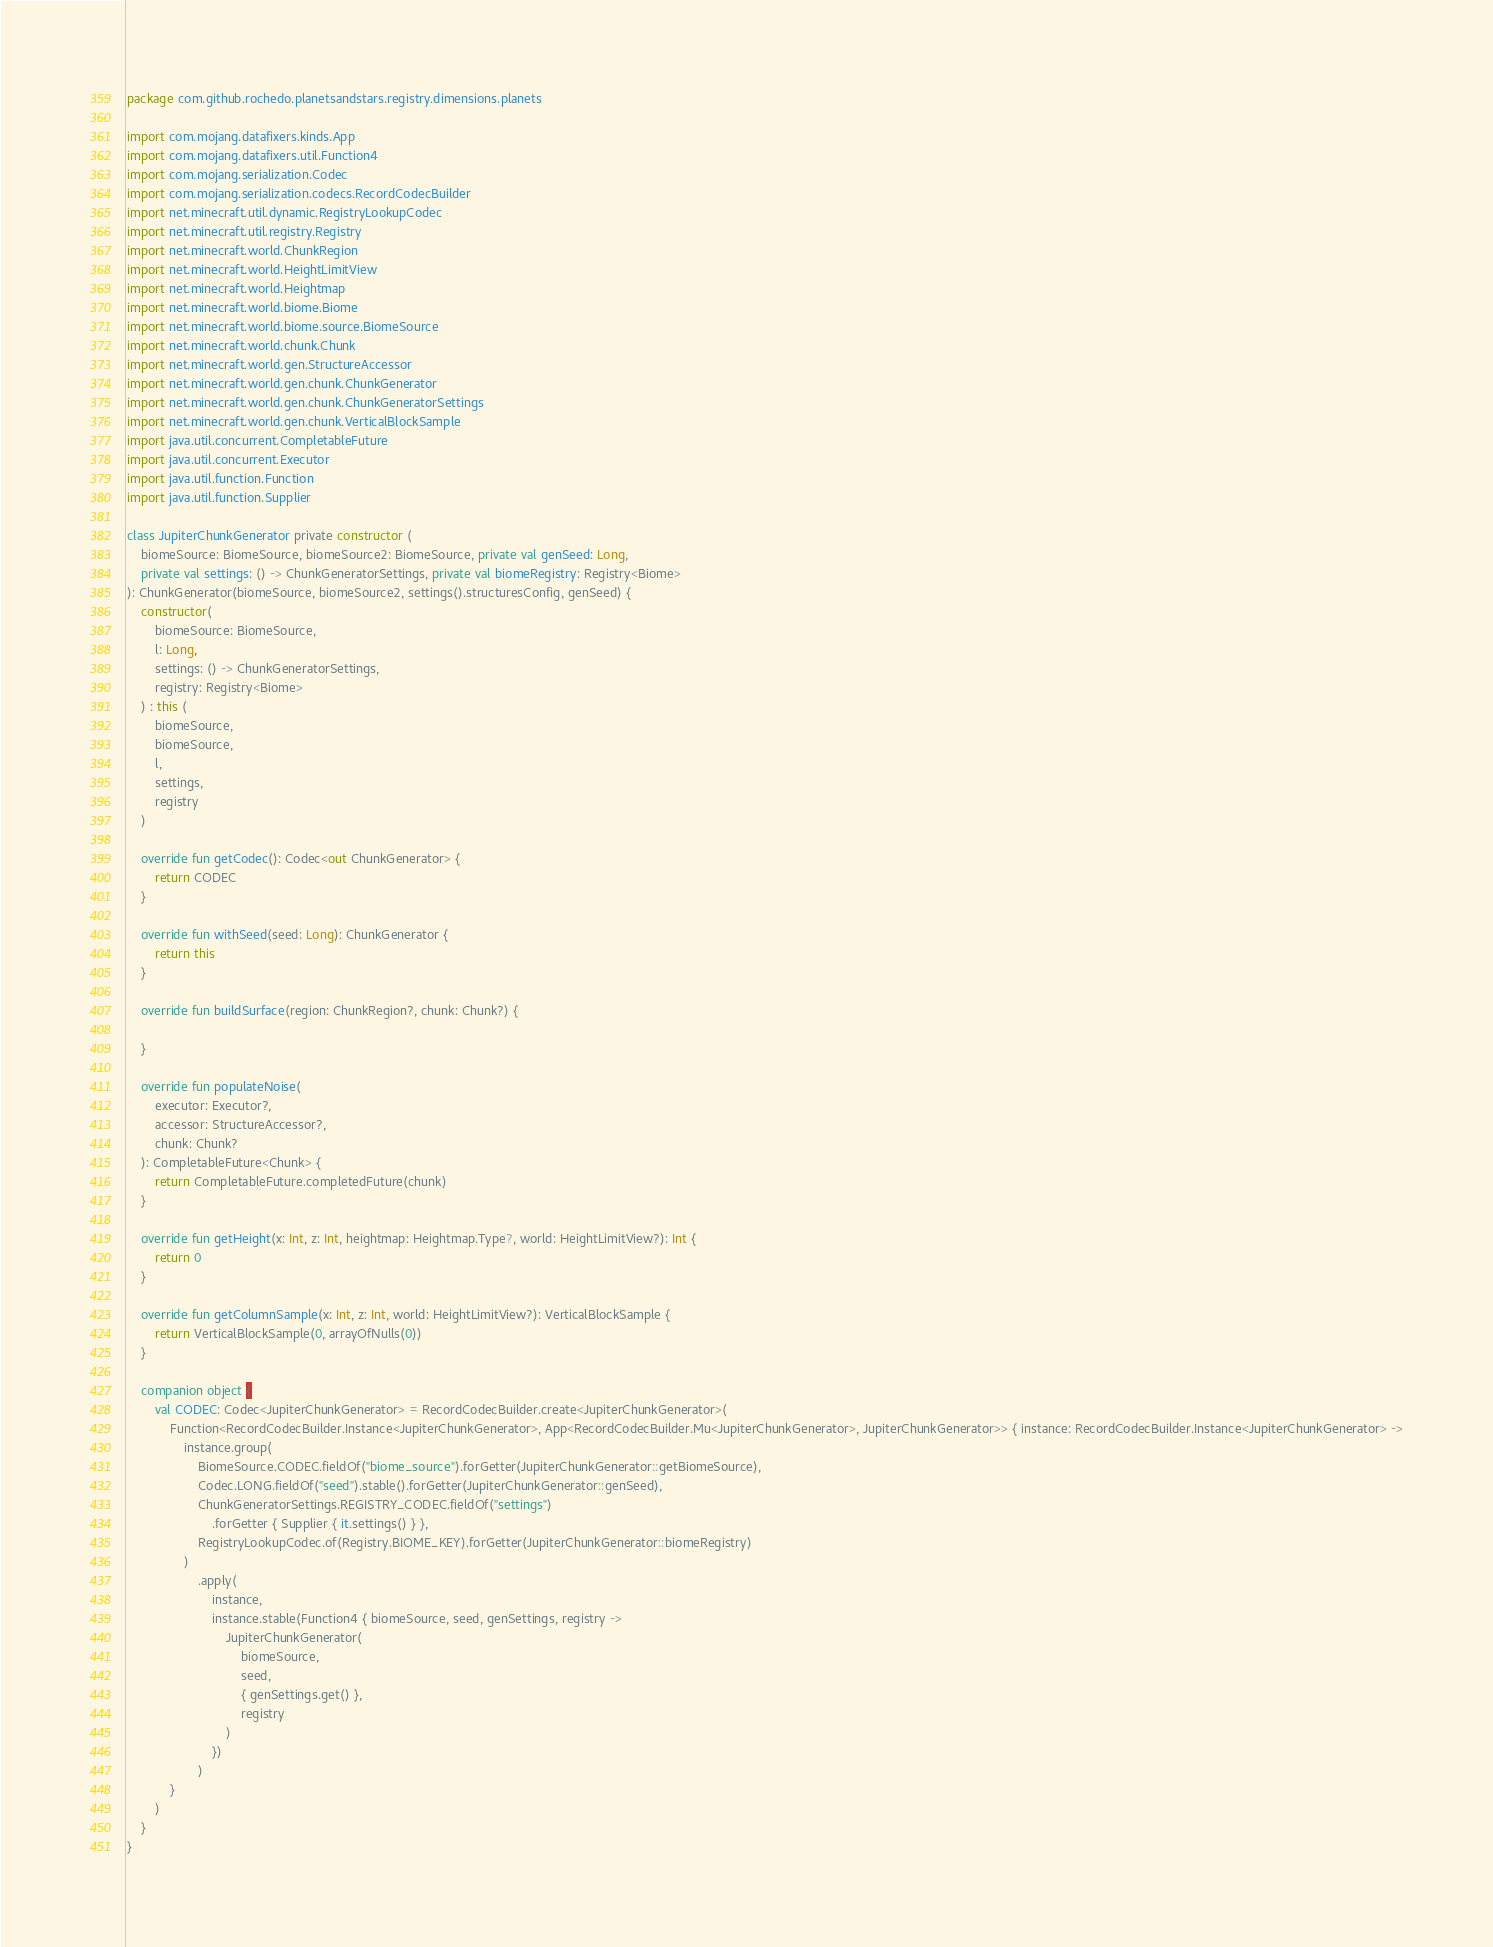Convert code to text. <code><loc_0><loc_0><loc_500><loc_500><_Kotlin_>package com.github.rochedo.planetsandstars.registry.dimensions.planets

import com.mojang.datafixers.kinds.App
import com.mojang.datafixers.util.Function4
import com.mojang.serialization.Codec
import com.mojang.serialization.codecs.RecordCodecBuilder
import net.minecraft.util.dynamic.RegistryLookupCodec
import net.minecraft.util.registry.Registry
import net.minecraft.world.ChunkRegion
import net.minecraft.world.HeightLimitView
import net.minecraft.world.Heightmap
import net.minecraft.world.biome.Biome
import net.minecraft.world.biome.source.BiomeSource
import net.minecraft.world.chunk.Chunk
import net.minecraft.world.gen.StructureAccessor
import net.minecraft.world.gen.chunk.ChunkGenerator
import net.minecraft.world.gen.chunk.ChunkGeneratorSettings
import net.minecraft.world.gen.chunk.VerticalBlockSample
import java.util.concurrent.CompletableFuture
import java.util.concurrent.Executor
import java.util.function.Function
import java.util.function.Supplier

class JupiterChunkGenerator private constructor (
    biomeSource: BiomeSource, biomeSource2: BiomeSource, private val genSeed: Long,
    private val settings: () -> ChunkGeneratorSettings, private val biomeRegistry: Registry<Biome>
): ChunkGenerator(biomeSource, biomeSource2, settings().structuresConfig, genSeed) {
    constructor(
        biomeSource: BiomeSource,
        l: Long,
        settings: () -> ChunkGeneratorSettings,
        registry: Registry<Biome>
    ) : this (
        biomeSource,
        biomeSource,
        l,
        settings,
        registry
    )

    override fun getCodec(): Codec<out ChunkGenerator> {
        return CODEC
    }

    override fun withSeed(seed: Long): ChunkGenerator {
        return this
    }

    override fun buildSurface(region: ChunkRegion?, chunk: Chunk?) {

    }

    override fun populateNoise(
        executor: Executor?,
        accessor: StructureAccessor?,
        chunk: Chunk?
    ): CompletableFuture<Chunk> {
        return CompletableFuture.completedFuture(chunk)
    }

    override fun getHeight(x: Int, z: Int, heightmap: Heightmap.Type?, world: HeightLimitView?): Int {
        return 0
    }

    override fun getColumnSample(x: Int, z: Int, world: HeightLimitView?): VerticalBlockSample {
        return VerticalBlockSample(0, arrayOfNulls(0))
    }

    companion object {
        val CODEC: Codec<JupiterChunkGenerator> = RecordCodecBuilder.create<JupiterChunkGenerator>(
            Function<RecordCodecBuilder.Instance<JupiterChunkGenerator>, App<RecordCodecBuilder.Mu<JupiterChunkGenerator>, JupiterChunkGenerator>> { instance: RecordCodecBuilder.Instance<JupiterChunkGenerator> ->
                instance.group(
                    BiomeSource.CODEC.fieldOf("biome_source").forGetter(JupiterChunkGenerator::getBiomeSource),
                    Codec.LONG.fieldOf("seed").stable().forGetter(JupiterChunkGenerator::genSeed),
                    ChunkGeneratorSettings.REGISTRY_CODEC.fieldOf("settings")
                        .forGetter { Supplier { it.settings() } },
                    RegistryLookupCodec.of(Registry.BIOME_KEY).forGetter(JupiterChunkGenerator::biomeRegistry)
                )
                    .apply(
                        instance,
                        instance.stable(Function4 { biomeSource, seed, genSettings, registry ->
                            JupiterChunkGenerator(
                                biomeSource,
                                seed,
                                { genSettings.get() },
                                registry
                            )
                        })
                    )
            }
        )
    }
}</code> 